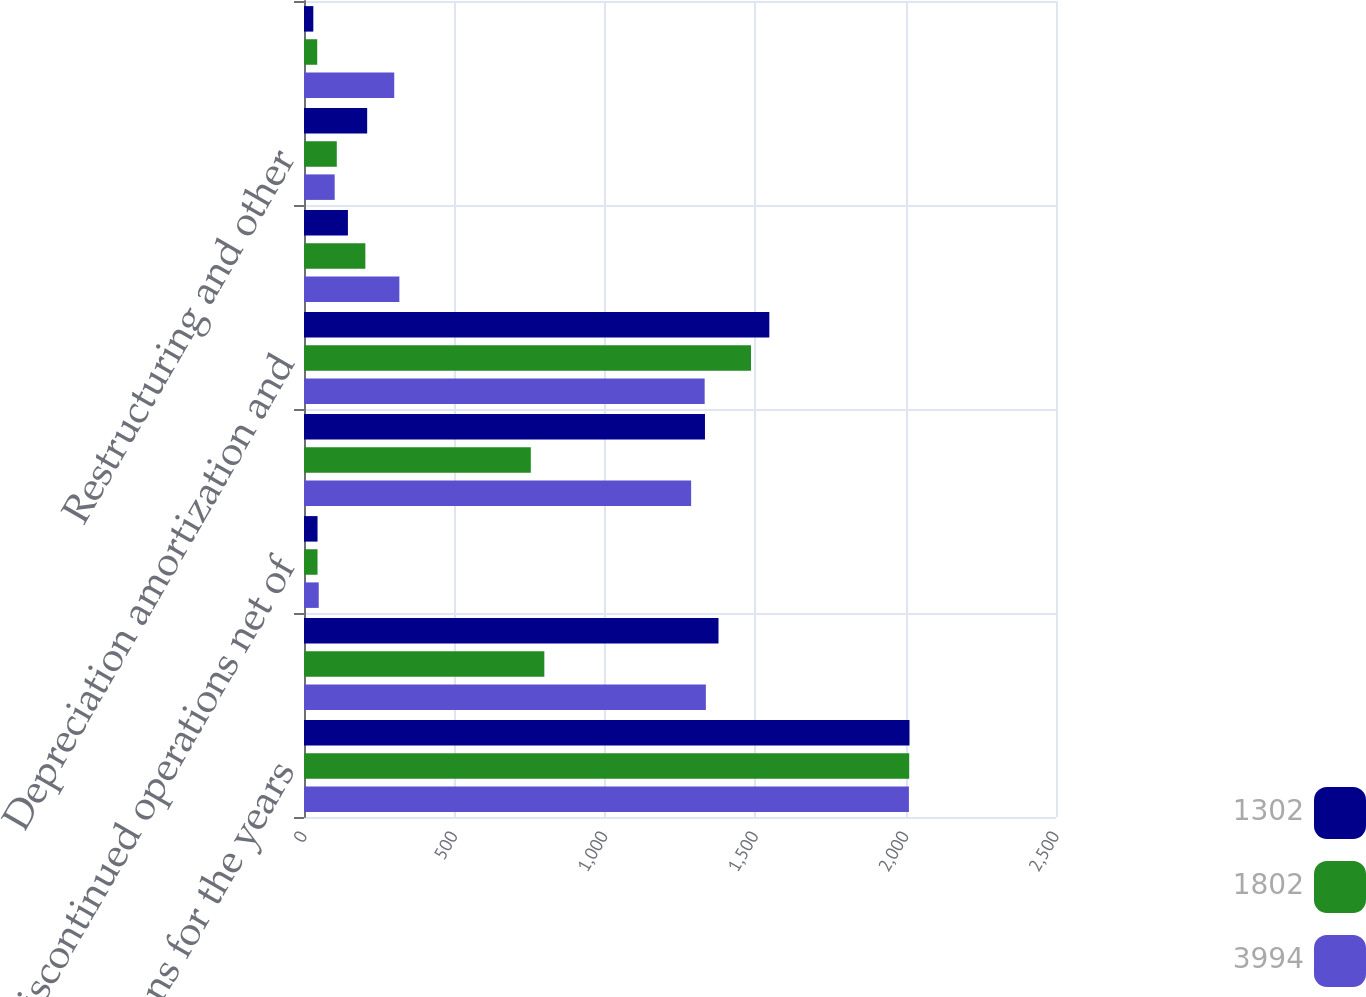Convert chart. <chart><loc_0><loc_0><loc_500><loc_500><stacked_bar_chart><ecel><fcel>In millions for the years<fcel>Net earnings (loss)<fcel>Discontinued operations net of<fcel>Earnings (loss) from<fcel>Depreciation amortization and<fcel>Deferred income tax provision<fcel>Restructuring and other<fcel>Pension plan contribution<nl><fcel>1302<fcel>2013<fcel>1378<fcel>45<fcel>1333<fcel>1547<fcel>146<fcel>210<fcel>31<nl><fcel>1802<fcel>2012<fcel>799<fcel>45<fcel>754<fcel>1486<fcel>204<fcel>109<fcel>44<nl><fcel>3994<fcel>2011<fcel>1336<fcel>49<fcel>1287<fcel>1332<fcel>317<fcel>102<fcel>300<nl></chart> 